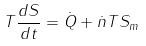Convert formula to latex. <formula><loc_0><loc_0><loc_500><loc_500>T \frac { d S } { d t } = \dot { Q } + \dot { n } T S _ { m }</formula> 